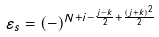Convert formula to latex. <formula><loc_0><loc_0><loc_500><loc_500>\varepsilon _ { s } = ( - ) ^ { N + i - \frac { j - k } { 2 } + \frac { ( j + k ) ^ { 2 } } { 2 } }</formula> 